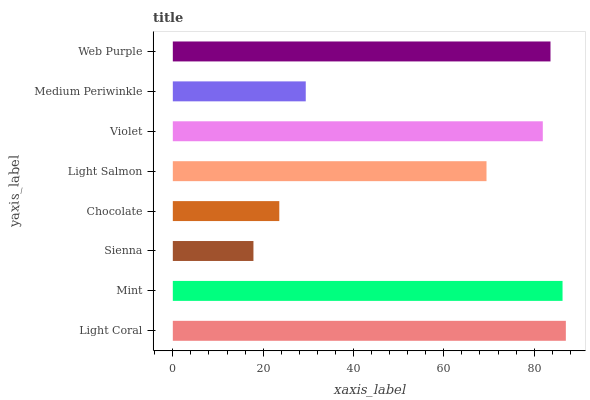Is Sienna the minimum?
Answer yes or no. Yes. Is Light Coral the maximum?
Answer yes or no. Yes. Is Mint the minimum?
Answer yes or no. No. Is Mint the maximum?
Answer yes or no. No. Is Light Coral greater than Mint?
Answer yes or no. Yes. Is Mint less than Light Coral?
Answer yes or no. Yes. Is Mint greater than Light Coral?
Answer yes or no. No. Is Light Coral less than Mint?
Answer yes or no. No. Is Violet the high median?
Answer yes or no. Yes. Is Light Salmon the low median?
Answer yes or no. Yes. Is Light Salmon the high median?
Answer yes or no. No. Is Medium Periwinkle the low median?
Answer yes or no. No. 